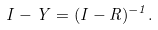<formula> <loc_0><loc_0><loc_500><loc_500>I - Y = ( I - R ) ^ { - 1 } .</formula> 